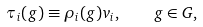Convert formula to latex. <formula><loc_0><loc_0><loc_500><loc_500>\tau _ { i } ( g ) \equiv \rho _ { i } ( g ) v _ { i } , \quad g \in G ,</formula> 